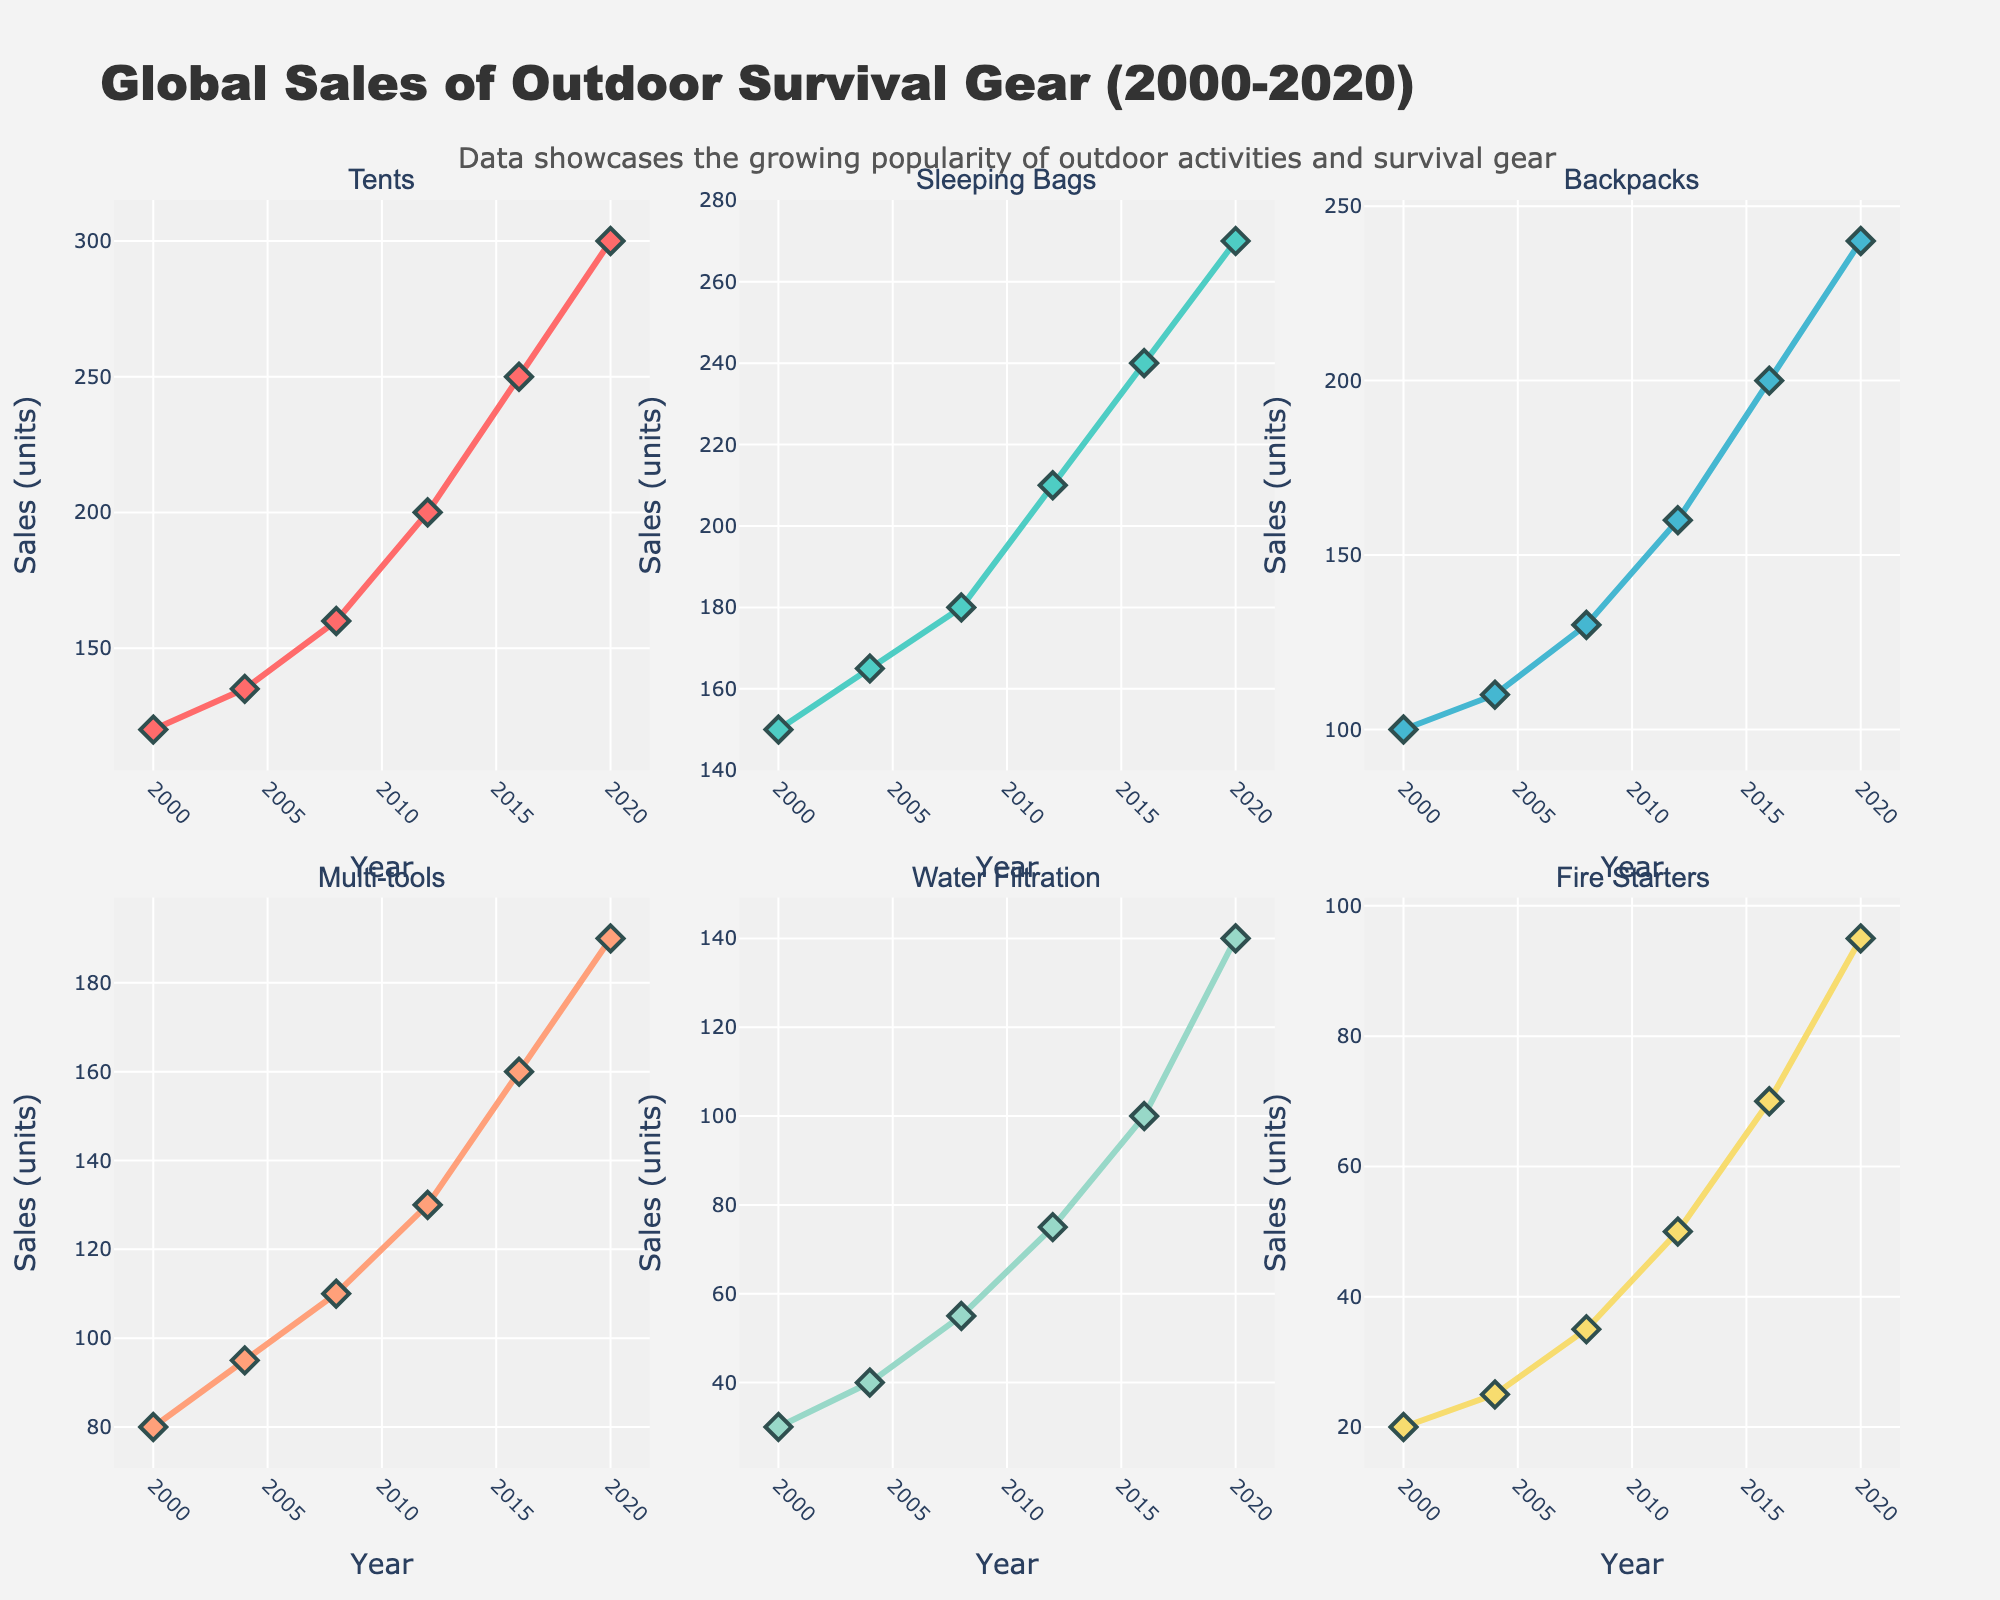What's the title of the figure? Look at the top of the figure where the title is usually placed. The title is "Global Sales of Outdoor Survival Gear (2000-2020)".
Answer: Global Sales of Outdoor Survival Gear (2000-2020) What category has the highest sales in 2020? Check the y-values for each category in the year 2020. The category with the highest y-value is "Tents".
Answer: Tents What is the total sales of "Backpacks" and "Multi-tools" in 2008? Locate the sales value for "Backpacks" and "Multi-tools" in 2008. Sum up these two values: 130 (Backpacks) + 110 (Multi-tools) = 240.
Answer: 240 How much did the sales of "Water Filtration" increase from 2000 to 2020? Find the sales values of "Water Filtration" for the years 2000 and 2020. Compute the difference: 140 (2020) - 30 (2000) = 110.
Answer: 110 Which item had the least growth in sales between 2000 and 2020? Calculate the difference in sales for each category between 2000 and 2020. Fire Starters had the smallest increase: 95 - 20 = 75.
Answer: Fire Starters Which two categories had nearly the same sales in 2004? Compare the sales values for each category in 2004. "Sleeping Bags" (165) and "Tents" (135) are relatively close but not the closest. "Backpacks" (110) and "Multi-tools" (95) are more similar.
Answer: Backpacks and Multi-tools What's the percentage increase in sales of "Tents" from 2000 to 2020? Find the sales values of "Tents" for the years 2000 and 2020. Calculate the percentage increase: ((300 - 120) / 120) * 100 = 150%.
Answer: 150% Which category showed a consistent increase in sales every four years? Observe the sales trend for each category over all six data points. All categories show an increase, but "Tents" follows a consistent upward trend in all intervals.
Answer: Tents What's the average sales of "Fire Starters" from 2000 to 2020? Find the sales values of "Fire Starters" for all the years. Compute the average: (20 + 25 + 35 + 50 + 70 + 95) / 6 = 49.17.
Answer: 49.17 Between "Multi-tools" and "Water Filtration," which had higher sales in 2016? Compare the 2016 sales values for "Multi-tools" and "Water Filtration". "Water Filtration" has 100 units sold while "Multi-tools" have 160 units sold.
Answer: Multi-tools 